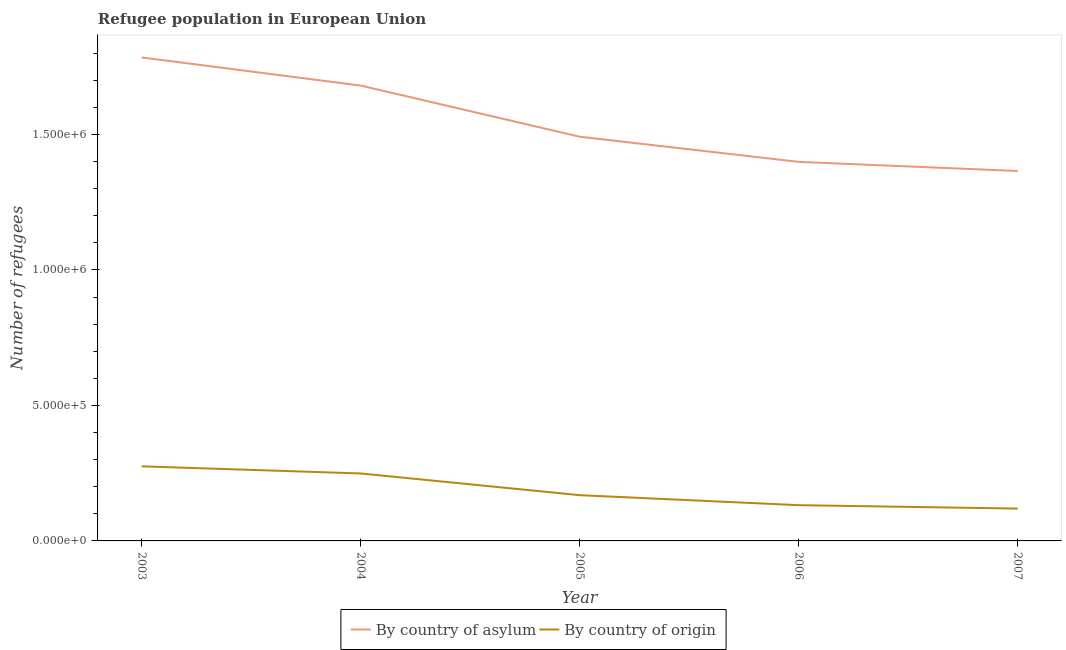How many different coloured lines are there?
Ensure brevity in your answer.  2. What is the number of refugees by country of asylum in 2005?
Provide a succinct answer. 1.49e+06. Across all years, what is the maximum number of refugees by country of origin?
Make the answer very short. 2.75e+05. Across all years, what is the minimum number of refugees by country of origin?
Ensure brevity in your answer.  1.19e+05. In which year was the number of refugees by country of asylum maximum?
Provide a short and direct response. 2003. In which year was the number of refugees by country of origin minimum?
Give a very brief answer. 2007. What is the total number of refugees by country of origin in the graph?
Give a very brief answer. 9.44e+05. What is the difference between the number of refugees by country of origin in 2005 and that in 2007?
Your answer should be compact. 4.94e+04. What is the difference between the number of refugees by country of asylum in 2006 and the number of refugees by country of origin in 2004?
Make the answer very short. 1.15e+06. What is the average number of refugees by country of asylum per year?
Your answer should be compact. 1.54e+06. In the year 2005, what is the difference between the number of refugees by country of origin and number of refugees by country of asylum?
Your answer should be very brief. -1.32e+06. What is the ratio of the number of refugees by country of origin in 2003 to that in 2006?
Offer a terse response. 2.09. Is the number of refugees by country of asylum in 2005 less than that in 2007?
Your response must be concise. No. Is the difference between the number of refugees by country of asylum in 2003 and 2004 greater than the difference between the number of refugees by country of origin in 2003 and 2004?
Your answer should be compact. Yes. What is the difference between the highest and the second highest number of refugees by country of origin?
Your response must be concise. 2.63e+04. What is the difference between the highest and the lowest number of refugees by country of asylum?
Your answer should be very brief. 4.19e+05. In how many years, is the number of refugees by country of asylum greater than the average number of refugees by country of asylum taken over all years?
Your response must be concise. 2. Is the sum of the number of refugees by country of origin in 2003 and 2006 greater than the maximum number of refugees by country of asylum across all years?
Ensure brevity in your answer.  No. Does the number of refugees by country of asylum monotonically increase over the years?
Keep it short and to the point. No. Is the number of refugees by country of asylum strictly less than the number of refugees by country of origin over the years?
Your answer should be compact. No. How many years are there in the graph?
Offer a terse response. 5. Are the values on the major ticks of Y-axis written in scientific E-notation?
Ensure brevity in your answer.  Yes. Does the graph contain grids?
Offer a terse response. No. Where does the legend appear in the graph?
Your answer should be compact. Bottom center. How are the legend labels stacked?
Ensure brevity in your answer.  Horizontal. What is the title of the graph?
Your answer should be compact. Refugee population in European Union. What is the label or title of the Y-axis?
Provide a short and direct response. Number of refugees. What is the Number of refugees of By country of asylum in 2003?
Your response must be concise. 1.78e+06. What is the Number of refugees of By country of origin in 2003?
Provide a succinct answer. 2.75e+05. What is the Number of refugees of By country of asylum in 2004?
Make the answer very short. 1.68e+06. What is the Number of refugees in By country of origin in 2004?
Offer a very short reply. 2.49e+05. What is the Number of refugees in By country of asylum in 2005?
Your response must be concise. 1.49e+06. What is the Number of refugees of By country of origin in 2005?
Make the answer very short. 1.69e+05. What is the Number of refugees of By country of asylum in 2006?
Keep it short and to the point. 1.40e+06. What is the Number of refugees in By country of origin in 2006?
Make the answer very short. 1.32e+05. What is the Number of refugees in By country of asylum in 2007?
Keep it short and to the point. 1.37e+06. What is the Number of refugees in By country of origin in 2007?
Offer a terse response. 1.19e+05. Across all years, what is the maximum Number of refugees in By country of asylum?
Your answer should be compact. 1.78e+06. Across all years, what is the maximum Number of refugees in By country of origin?
Give a very brief answer. 2.75e+05. Across all years, what is the minimum Number of refugees of By country of asylum?
Offer a terse response. 1.37e+06. Across all years, what is the minimum Number of refugees of By country of origin?
Ensure brevity in your answer.  1.19e+05. What is the total Number of refugees of By country of asylum in the graph?
Provide a short and direct response. 7.72e+06. What is the total Number of refugees of By country of origin in the graph?
Offer a terse response. 9.44e+05. What is the difference between the Number of refugees in By country of asylum in 2003 and that in 2004?
Your response must be concise. 1.04e+05. What is the difference between the Number of refugees in By country of origin in 2003 and that in 2004?
Your answer should be compact. 2.63e+04. What is the difference between the Number of refugees of By country of asylum in 2003 and that in 2005?
Ensure brevity in your answer.  2.93e+05. What is the difference between the Number of refugees in By country of origin in 2003 and that in 2005?
Offer a terse response. 1.06e+05. What is the difference between the Number of refugees of By country of asylum in 2003 and that in 2006?
Your answer should be compact. 3.85e+05. What is the difference between the Number of refugees of By country of origin in 2003 and that in 2006?
Give a very brief answer. 1.43e+05. What is the difference between the Number of refugees in By country of asylum in 2003 and that in 2007?
Offer a terse response. 4.19e+05. What is the difference between the Number of refugees of By country of origin in 2003 and that in 2007?
Keep it short and to the point. 1.56e+05. What is the difference between the Number of refugees of By country of asylum in 2004 and that in 2005?
Your response must be concise. 1.89e+05. What is the difference between the Number of refugees in By country of origin in 2004 and that in 2005?
Offer a very short reply. 8.01e+04. What is the difference between the Number of refugees of By country of asylum in 2004 and that in 2006?
Ensure brevity in your answer.  2.82e+05. What is the difference between the Number of refugees of By country of origin in 2004 and that in 2006?
Offer a very short reply. 1.17e+05. What is the difference between the Number of refugees of By country of asylum in 2004 and that in 2007?
Offer a terse response. 3.15e+05. What is the difference between the Number of refugees in By country of origin in 2004 and that in 2007?
Provide a succinct answer. 1.30e+05. What is the difference between the Number of refugees in By country of asylum in 2005 and that in 2006?
Give a very brief answer. 9.28e+04. What is the difference between the Number of refugees of By country of origin in 2005 and that in 2006?
Ensure brevity in your answer.  3.69e+04. What is the difference between the Number of refugees of By country of asylum in 2005 and that in 2007?
Provide a short and direct response. 1.27e+05. What is the difference between the Number of refugees in By country of origin in 2005 and that in 2007?
Make the answer very short. 4.94e+04. What is the difference between the Number of refugees in By country of asylum in 2006 and that in 2007?
Make the answer very short. 3.37e+04. What is the difference between the Number of refugees of By country of origin in 2006 and that in 2007?
Your answer should be compact. 1.26e+04. What is the difference between the Number of refugees of By country of asylum in 2003 and the Number of refugees of By country of origin in 2004?
Your answer should be compact. 1.54e+06. What is the difference between the Number of refugees of By country of asylum in 2003 and the Number of refugees of By country of origin in 2005?
Offer a terse response. 1.62e+06. What is the difference between the Number of refugees in By country of asylum in 2003 and the Number of refugees in By country of origin in 2006?
Offer a very short reply. 1.65e+06. What is the difference between the Number of refugees in By country of asylum in 2003 and the Number of refugees in By country of origin in 2007?
Make the answer very short. 1.66e+06. What is the difference between the Number of refugees of By country of asylum in 2004 and the Number of refugees of By country of origin in 2005?
Make the answer very short. 1.51e+06. What is the difference between the Number of refugees in By country of asylum in 2004 and the Number of refugees in By country of origin in 2006?
Make the answer very short. 1.55e+06. What is the difference between the Number of refugees of By country of asylum in 2004 and the Number of refugees of By country of origin in 2007?
Keep it short and to the point. 1.56e+06. What is the difference between the Number of refugees of By country of asylum in 2005 and the Number of refugees of By country of origin in 2006?
Your answer should be very brief. 1.36e+06. What is the difference between the Number of refugees in By country of asylum in 2005 and the Number of refugees in By country of origin in 2007?
Ensure brevity in your answer.  1.37e+06. What is the difference between the Number of refugees of By country of asylum in 2006 and the Number of refugees of By country of origin in 2007?
Offer a very short reply. 1.28e+06. What is the average Number of refugees in By country of asylum per year?
Keep it short and to the point. 1.54e+06. What is the average Number of refugees in By country of origin per year?
Your answer should be very brief. 1.89e+05. In the year 2003, what is the difference between the Number of refugees in By country of asylum and Number of refugees in By country of origin?
Give a very brief answer. 1.51e+06. In the year 2004, what is the difference between the Number of refugees in By country of asylum and Number of refugees in By country of origin?
Your response must be concise. 1.43e+06. In the year 2005, what is the difference between the Number of refugees of By country of asylum and Number of refugees of By country of origin?
Offer a terse response. 1.32e+06. In the year 2006, what is the difference between the Number of refugees in By country of asylum and Number of refugees in By country of origin?
Give a very brief answer. 1.27e+06. In the year 2007, what is the difference between the Number of refugees in By country of asylum and Number of refugees in By country of origin?
Provide a short and direct response. 1.25e+06. What is the ratio of the Number of refugees of By country of asylum in 2003 to that in 2004?
Give a very brief answer. 1.06. What is the ratio of the Number of refugees of By country of origin in 2003 to that in 2004?
Offer a terse response. 1.11. What is the ratio of the Number of refugees of By country of asylum in 2003 to that in 2005?
Your answer should be compact. 1.2. What is the ratio of the Number of refugees in By country of origin in 2003 to that in 2005?
Your answer should be compact. 1.63. What is the ratio of the Number of refugees in By country of asylum in 2003 to that in 2006?
Provide a succinct answer. 1.28. What is the ratio of the Number of refugees of By country of origin in 2003 to that in 2006?
Offer a terse response. 2.09. What is the ratio of the Number of refugees of By country of asylum in 2003 to that in 2007?
Provide a succinct answer. 1.31. What is the ratio of the Number of refugees in By country of origin in 2003 to that in 2007?
Your answer should be very brief. 2.31. What is the ratio of the Number of refugees of By country of asylum in 2004 to that in 2005?
Ensure brevity in your answer.  1.13. What is the ratio of the Number of refugees of By country of origin in 2004 to that in 2005?
Provide a succinct answer. 1.47. What is the ratio of the Number of refugees of By country of asylum in 2004 to that in 2006?
Your response must be concise. 1.2. What is the ratio of the Number of refugees of By country of origin in 2004 to that in 2006?
Offer a very short reply. 1.89. What is the ratio of the Number of refugees in By country of asylum in 2004 to that in 2007?
Provide a succinct answer. 1.23. What is the ratio of the Number of refugees in By country of origin in 2004 to that in 2007?
Keep it short and to the point. 2.09. What is the ratio of the Number of refugees of By country of asylum in 2005 to that in 2006?
Give a very brief answer. 1.07. What is the ratio of the Number of refugees of By country of origin in 2005 to that in 2006?
Keep it short and to the point. 1.28. What is the ratio of the Number of refugees of By country of asylum in 2005 to that in 2007?
Offer a very short reply. 1.09. What is the ratio of the Number of refugees of By country of origin in 2005 to that in 2007?
Offer a very short reply. 1.41. What is the ratio of the Number of refugees in By country of asylum in 2006 to that in 2007?
Ensure brevity in your answer.  1.02. What is the ratio of the Number of refugees of By country of origin in 2006 to that in 2007?
Ensure brevity in your answer.  1.11. What is the difference between the highest and the second highest Number of refugees of By country of asylum?
Give a very brief answer. 1.04e+05. What is the difference between the highest and the second highest Number of refugees in By country of origin?
Your response must be concise. 2.63e+04. What is the difference between the highest and the lowest Number of refugees in By country of asylum?
Give a very brief answer. 4.19e+05. What is the difference between the highest and the lowest Number of refugees in By country of origin?
Your response must be concise. 1.56e+05. 